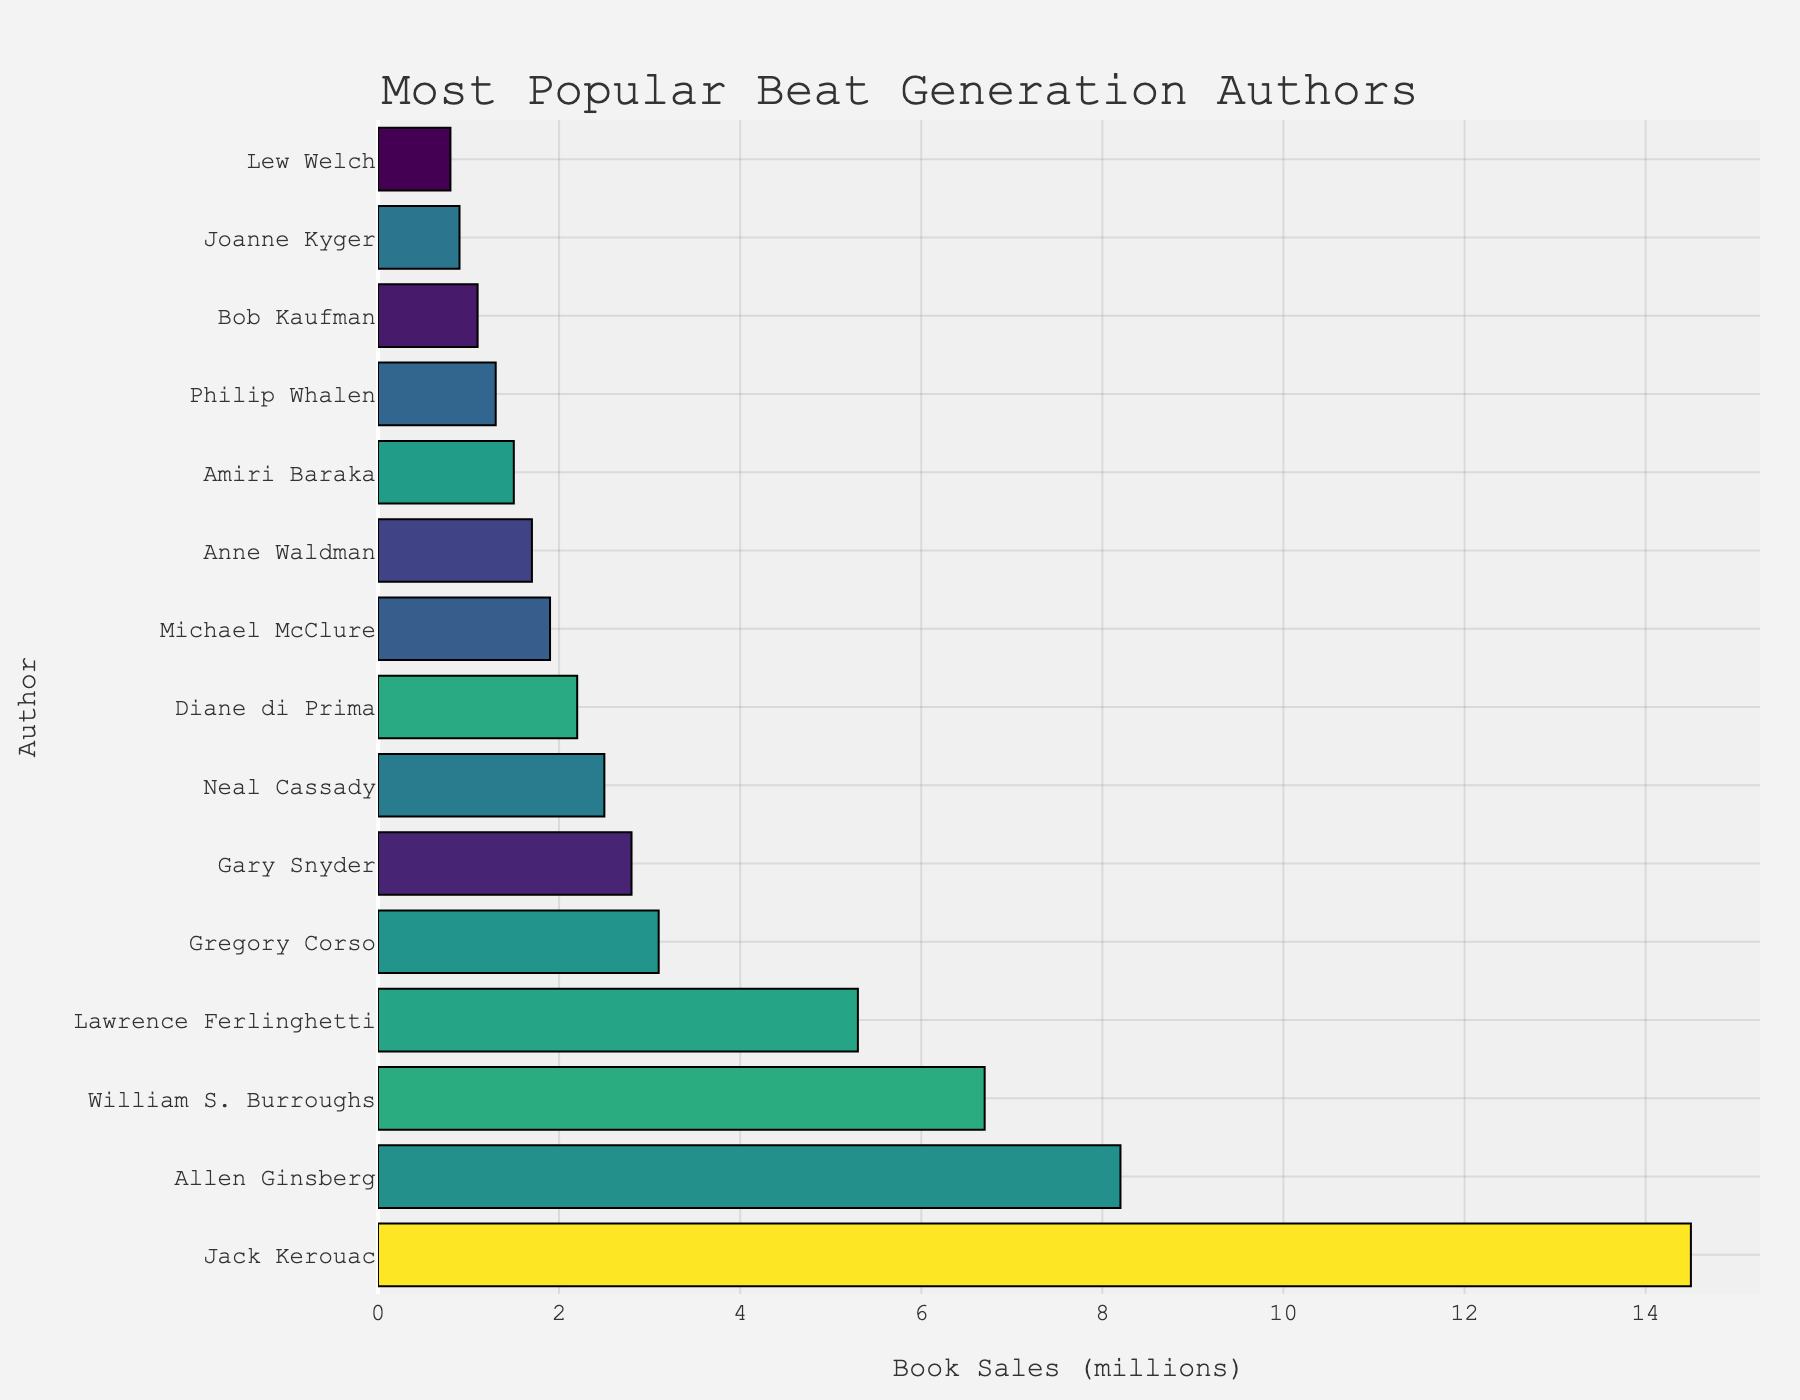Which author has the highest book sales? The figure shows the bar lengths for each author, where the longest bar represents the author with the highest book sales. Jack Kerouac has the longest bar.
Answer: Jack Kerouac What's the combined book sales for Allen Ginsberg and William S. Burroughs? Look at the bar lengths for Allen Ginsberg and William S. Burroughs. Add their book sales: 8.2 million (Ginsberg) + 6.7 million (Burroughs) = 14.9 million.
Answer: 14.9 million Who has sold more books, Diane di Prima or Neal Cassady? Compare the bar lengths for Diane di Prima and Neal Cassady. Neal Cassady's bar is longer than Diane di Prima's.
Answer: Neal Cassady What's the difference in book sales between the most and least popular authors? Find the book sales for the most popular author (Jack Kerouac) and the least popular author (Lew Welch). Subtract the latter from the former: 14.5 million (Kerouac) - 0.8 million (Welch) = 13.7 million.
Answer: 13.7 million How many authors have book sales greater than 5 million? Count the bars representing authors with book sales that extend past the 5 million mark. The authors are Jack Kerouac, Allen Ginsberg, William S. Burroughs, and Lawrence Ferlinghetti, making a total of four.
Answer: 4 Which author has book sales closest to the average book sales of the top 5 authors? Calculate the average book sales for the top 5 authors (Jack Kerouac, Allen Ginsberg, William S. Burroughs, Lawrence Ferlinghetti, Gregory Corso). Their sales are: 14.5 + 8.2 + 6.7 + 5.3 + 3.1 = 37.8 million; average is 37.8 / 5 = 7.56 million. Compare and find Gregory Corso closer to this average (3.1 million) compared to others.
Answer: Gregory Corso 